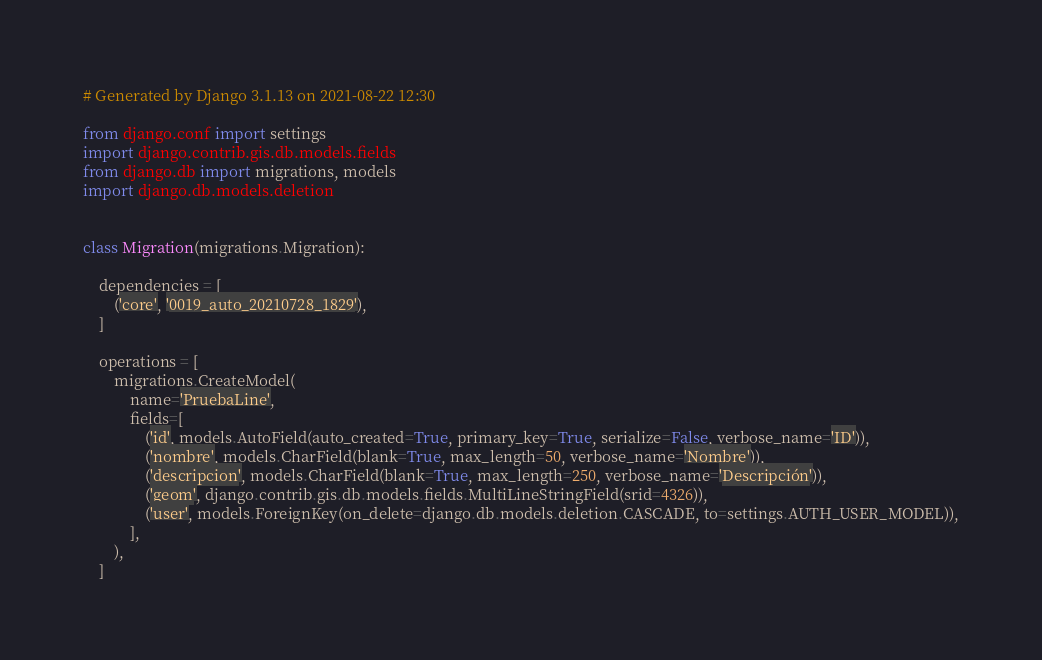Convert code to text. <code><loc_0><loc_0><loc_500><loc_500><_Python_># Generated by Django 3.1.13 on 2021-08-22 12:30

from django.conf import settings
import django.contrib.gis.db.models.fields
from django.db import migrations, models
import django.db.models.deletion


class Migration(migrations.Migration):

    dependencies = [
        ('core', '0019_auto_20210728_1829'),
    ]

    operations = [
        migrations.CreateModel(
            name='PruebaLine',
            fields=[
                ('id', models.AutoField(auto_created=True, primary_key=True, serialize=False, verbose_name='ID')),
                ('nombre', models.CharField(blank=True, max_length=50, verbose_name='Nombre')),
                ('descripcion', models.CharField(blank=True, max_length=250, verbose_name='Descripción')),
                ('geom', django.contrib.gis.db.models.fields.MultiLineStringField(srid=4326)),
                ('user', models.ForeignKey(on_delete=django.db.models.deletion.CASCADE, to=settings.AUTH_USER_MODEL)),
            ],
        ),
    ]
</code> 